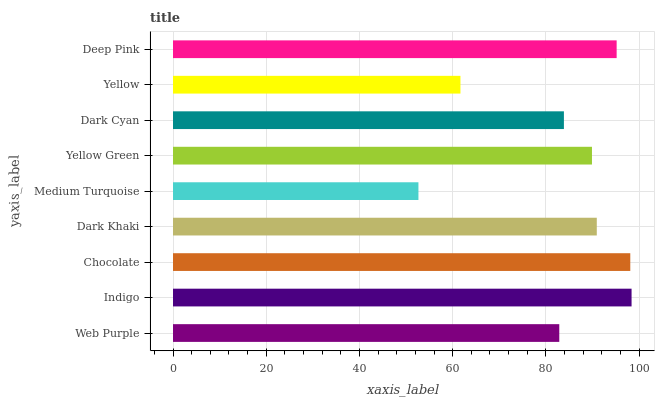Is Medium Turquoise the minimum?
Answer yes or no. Yes. Is Indigo the maximum?
Answer yes or no. Yes. Is Chocolate the minimum?
Answer yes or no. No. Is Chocolate the maximum?
Answer yes or no. No. Is Indigo greater than Chocolate?
Answer yes or no. Yes. Is Chocolate less than Indigo?
Answer yes or no. Yes. Is Chocolate greater than Indigo?
Answer yes or no. No. Is Indigo less than Chocolate?
Answer yes or no. No. Is Yellow Green the high median?
Answer yes or no. Yes. Is Yellow Green the low median?
Answer yes or no. Yes. Is Dark Khaki the high median?
Answer yes or no. No. Is Web Purple the low median?
Answer yes or no. No. 